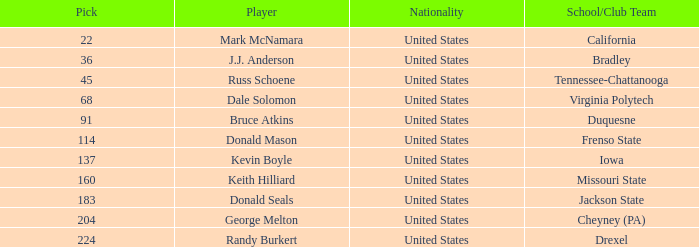To which nation does the drexel competitor with a pick surpassing 183 belong? United States. 